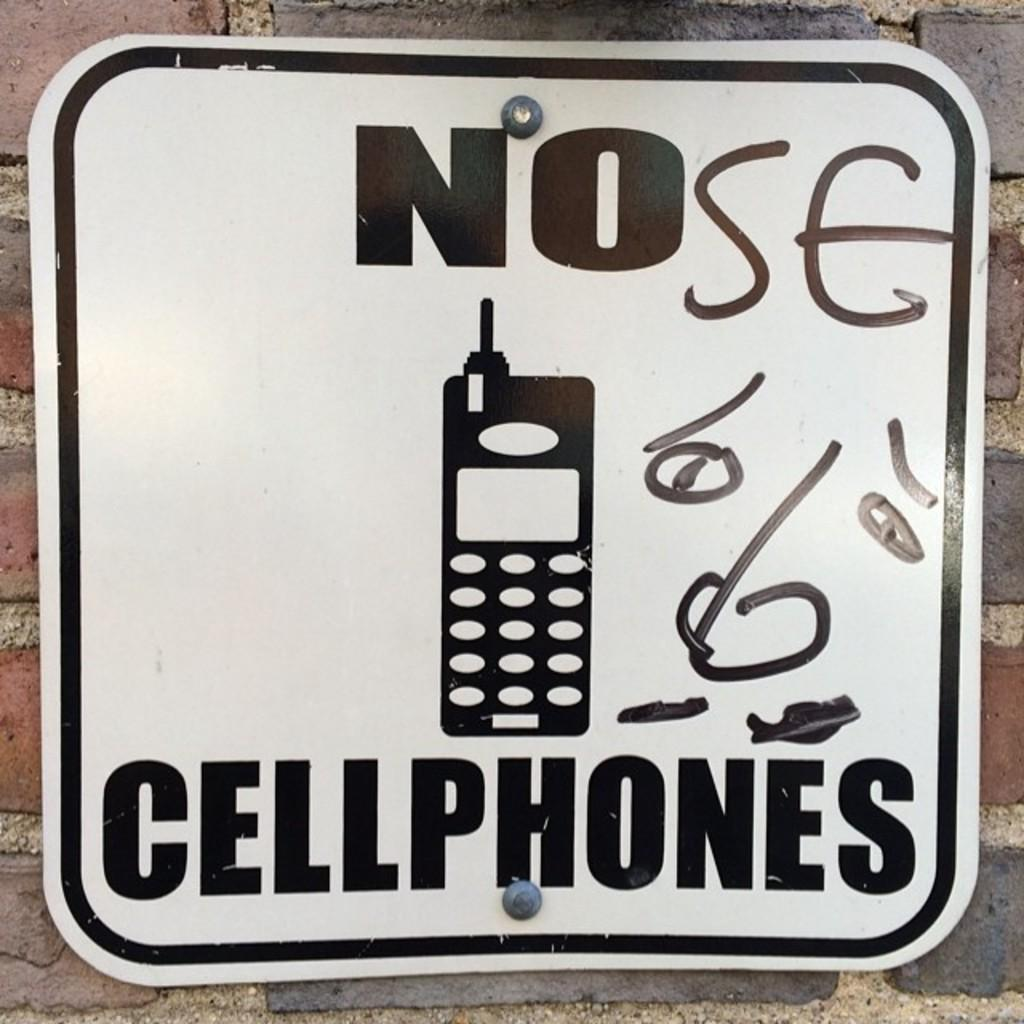What can be found in the image that contains written information? There is text in the image. What type of object is depicted in the image? There is an image of a device in the image. What else is present on the board in the image? There are a few things on the board in the image. Where is the board located in the image? The board is visible on a brick wall. How many cattle can be seen grazing near the brick wall in the image? There are no cattle present in the image; it features a board with text and an image of a device on a brick wall. What type of cable is connected to the device in the image? There is no cable connected to the device in the image; only the device and text are present. 